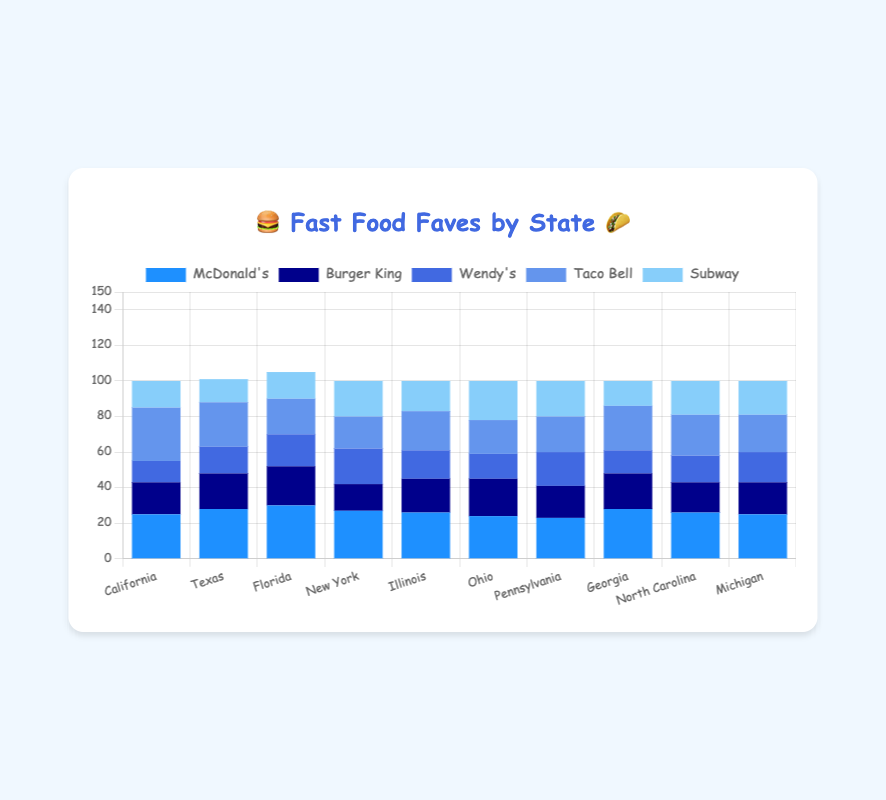Which state prefers McDonald's the most? Florida prefers McDonald's the most with a bar height of 30.
Answer: Florida Which fast food chain is the least popular in California? The bar for Wendy's is the shortest in California, with a height of 12, making it the least popular chain there.
Answer: Wendy's How many more people in Texas prefer McDonald's compared to Subway? The bar for McDonald's in Texas is at 28, and Subway is at 13. The difference is 28 - 13 = 15.
Answer: 15 What is the total number of people preferring Taco Bell across all states? Summing up the bar heights for Taco Bell in all states: 30 + 25 + 20 + 18 + 22 + 19 + 20 + 25 + 23 + 21 = 223.
Answer: 223 Which chain has the most consistent popularity (least variation) across states? Subway's bars are fairly consistent across states, with values ranging from 13 to 22, showing the least variation.
Answer: Subway Which state has the highest combined preference for McDonald's and Taco Bell? For each state:
   - California: 25 + 30 = 55
   - Texas: 28 + 25 = 53
   - Florida: 30 + 20 = 50
   - New York: 27 + 18 = 45
   - Illinois: 26 + 22 = 48
   - Ohio: 24 + 19 = 43
   - Pennsylvania: 23 + 20 = 43
   - Georgia: 28 + 25 = 53
   - North Carolina: 26 + 23 = 49
   - Michigan: 25 + 21 = 46
California has the highest combined preference at 55.
Answer: California What is the average preference for Burger King across all states? Summing the bar heights for Burger King across all states and dividing by the number of states: (18 + 20 + 22 + 15 + 19 + 21 + 18 + 20 + 17 + 18) / 10 = 19.
Answer: 19 Which state shows the highest preference for Wendy's? The tallest bar for Wendy's is in New York, with a height of 20.
Answer: New York How many states show a higher preference for McDonald's than for Wendy's? Comparing the bars for McDonald's and Wendy's in each state, all 10 states have a higher bar for McDonald's than for Wendy's.
Answer: 10 Which state has the lowest total preference across all fast food chains? Calculating the totals:
   - California: 25 + 18 + 12 + 30 + 15 = 100
   - Texas: 28 + 20 + 15 + 25 + 13 = 101
   - Florida: 30 + 22 + 18 + 20 + 15 = 105
   - New York: 27 + 15 + 20 + 18 + 20 = 100
   - Illinois: 26 + 19 + 16 + 22 + 17 = 100
   - Ohio: 24 + 21 + 14 + 19 + 22 = 100
   - Pennsylvania: 23 + 18 + 19 + 20 + 20 = 100
   - Georgia: 28 + 20 + 13 + 25 + 14 = 100
   - North Carolina: 26 + 17 + 15 + 23 + 19 = 100
   - Michigan: 25 + 18 + 17 + 21 + 19 = 100
All states except Texas and Florida have the lowest total preference, which is 100.
Answer: California, New York, Illinois, Ohio, Pennsylvania, Georgia, North Carolina, and Michigan 